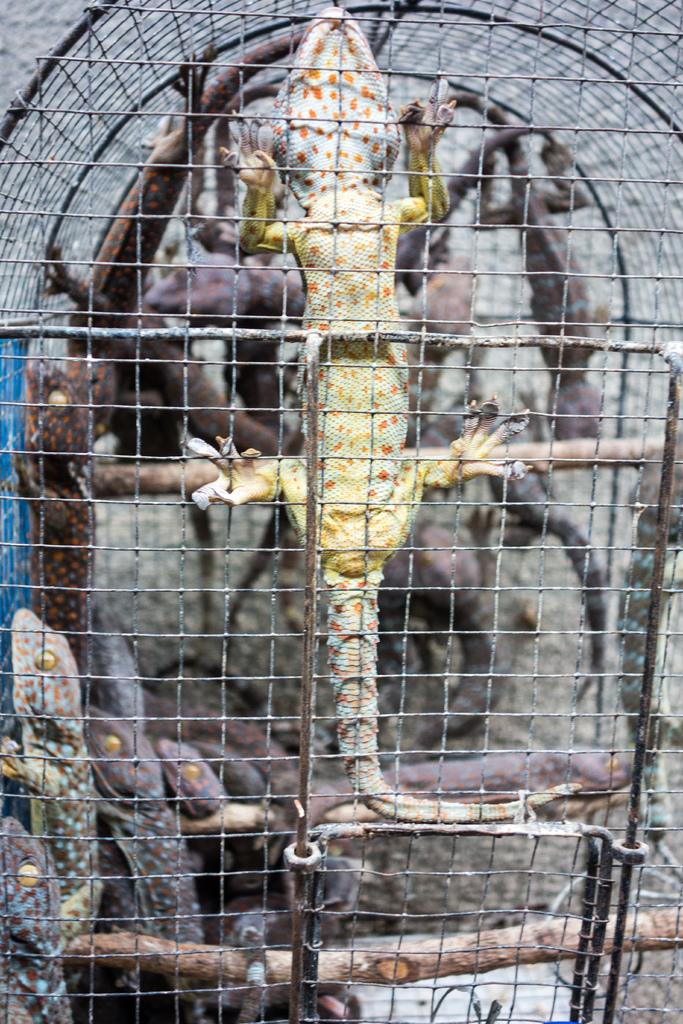What type of animals are present in the image? There are reptiles in the image. What can be seen in the image besides the reptiles? There is an iron grill in the image. What type of chalk is being used by the secretary in the image? There is no secretary or chalk present in the image; it only features reptiles and an iron grill. 